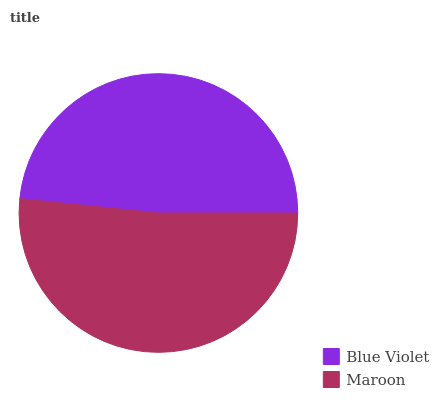Is Blue Violet the minimum?
Answer yes or no. Yes. Is Maroon the maximum?
Answer yes or no. Yes. Is Maroon the minimum?
Answer yes or no. No. Is Maroon greater than Blue Violet?
Answer yes or no. Yes. Is Blue Violet less than Maroon?
Answer yes or no. Yes. Is Blue Violet greater than Maroon?
Answer yes or no. No. Is Maroon less than Blue Violet?
Answer yes or no. No. Is Maroon the high median?
Answer yes or no. Yes. Is Blue Violet the low median?
Answer yes or no. Yes. Is Blue Violet the high median?
Answer yes or no. No. Is Maroon the low median?
Answer yes or no. No. 